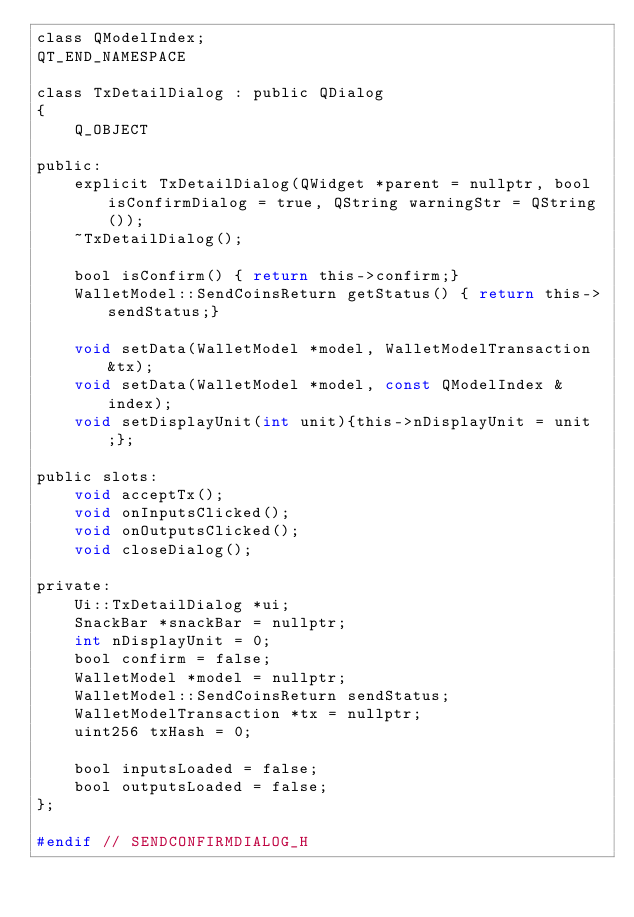Convert code to text. <code><loc_0><loc_0><loc_500><loc_500><_C_>class QModelIndex;
QT_END_NAMESPACE

class TxDetailDialog : public QDialog
{
    Q_OBJECT

public:
    explicit TxDetailDialog(QWidget *parent = nullptr, bool isConfirmDialog = true, QString warningStr = QString());
    ~TxDetailDialog();

    bool isConfirm() { return this->confirm;}
    WalletModel::SendCoinsReturn getStatus() { return this->sendStatus;}

    void setData(WalletModel *model, WalletModelTransaction &tx);
    void setData(WalletModel *model, const QModelIndex &index);
    void setDisplayUnit(int unit){this->nDisplayUnit = unit;};

public slots:
    void acceptTx();
    void onInputsClicked();
    void onOutputsClicked();
    void closeDialog();

private:
    Ui::TxDetailDialog *ui;
    SnackBar *snackBar = nullptr;
    int nDisplayUnit = 0;
    bool confirm = false;
    WalletModel *model = nullptr;
    WalletModel::SendCoinsReturn sendStatus;
    WalletModelTransaction *tx = nullptr;
    uint256 txHash = 0;

    bool inputsLoaded = false;
    bool outputsLoaded = false;
};

#endif // SENDCONFIRMDIALOG_H
</code> 